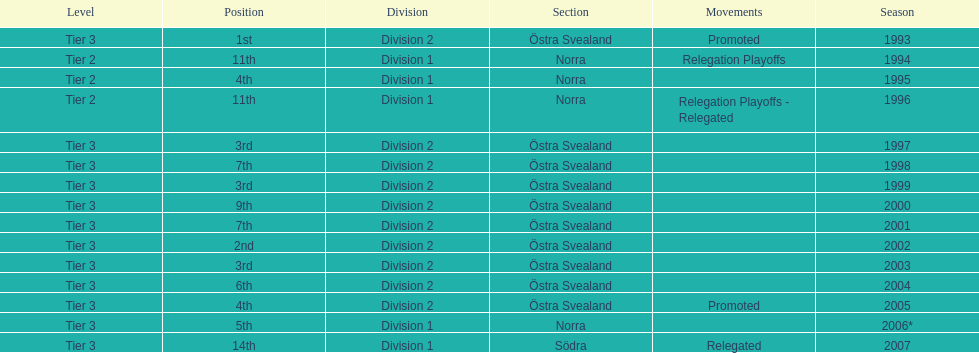How many times is division 2 listed as the division? 10. 